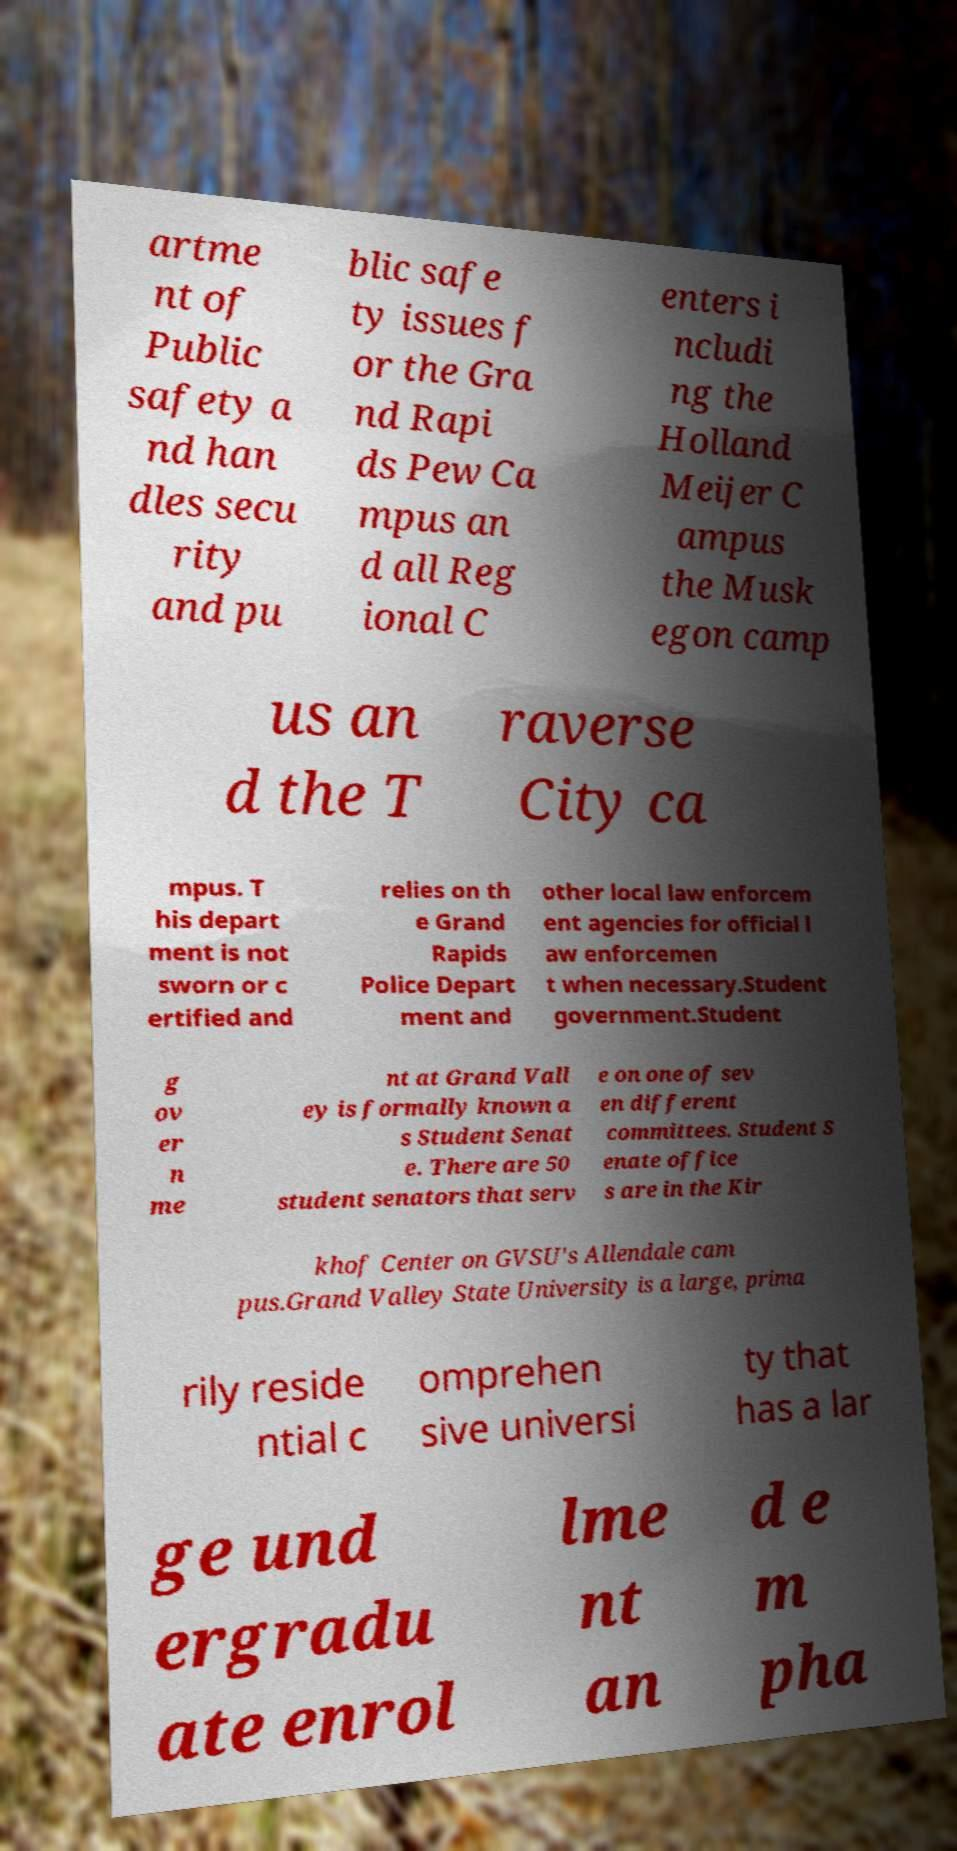Could you extract and type out the text from this image? artme nt of Public safety a nd han dles secu rity and pu blic safe ty issues f or the Gra nd Rapi ds Pew Ca mpus an d all Reg ional C enters i ncludi ng the Holland Meijer C ampus the Musk egon camp us an d the T raverse City ca mpus. T his depart ment is not sworn or c ertified and relies on th e Grand Rapids Police Depart ment and other local law enforcem ent agencies for official l aw enforcemen t when necessary.Student government.Student g ov er n me nt at Grand Vall ey is formally known a s Student Senat e. There are 50 student senators that serv e on one of sev en different committees. Student S enate office s are in the Kir khof Center on GVSU's Allendale cam pus.Grand Valley State University is a large, prima rily reside ntial c omprehen sive universi ty that has a lar ge und ergradu ate enrol lme nt an d e m pha 